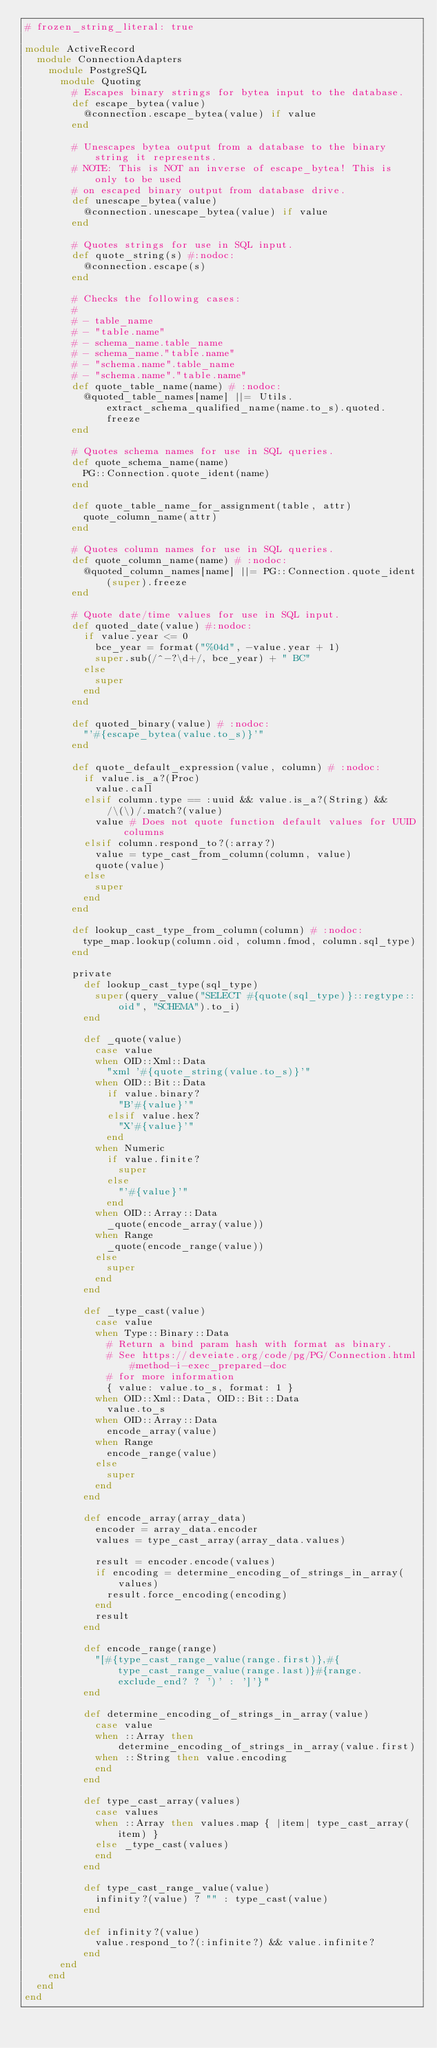Convert code to text. <code><loc_0><loc_0><loc_500><loc_500><_Ruby_># frozen_string_literal: true

module ActiveRecord
  module ConnectionAdapters
    module PostgreSQL
      module Quoting
        # Escapes binary strings for bytea input to the database.
        def escape_bytea(value)
          @connection.escape_bytea(value) if value
        end

        # Unescapes bytea output from a database to the binary string it represents.
        # NOTE: This is NOT an inverse of escape_bytea! This is only to be used
        # on escaped binary output from database drive.
        def unescape_bytea(value)
          @connection.unescape_bytea(value) if value
        end

        # Quotes strings for use in SQL input.
        def quote_string(s) #:nodoc:
          @connection.escape(s)
        end

        # Checks the following cases:
        #
        # - table_name
        # - "table.name"
        # - schema_name.table_name
        # - schema_name."table.name"
        # - "schema.name".table_name
        # - "schema.name"."table.name"
        def quote_table_name(name) # :nodoc:
          @quoted_table_names[name] ||= Utils.extract_schema_qualified_name(name.to_s).quoted.freeze
        end

        # Quotes schema names for use in SQL queries.
        def quote_schema_name(name)
          PG::Connection.quote_ident(name)
        end

        def quote_table_name_for_assignment(table, attr)
          quote_column_name(attr)
        end

        # Quotes column names for use in SQL queries.
        def quote_column_name(name) # :nodoc:
          @quoted_column_names[name] ||= PG::Connection.quote_ident(super).freeze
        end

        # Quote date/time values for use in SQL input.
        def quoted_date(value) #:nodoc:
          if value.year <= 0
            bce_year = format("%04d", -value.year + 1)
            super.sub(/^-?\d+/, bce_year) + " BC"
          else
            super
          end
        end

        def quoted_binary(value) # :nodoc:
          "'#{escape_bytea(value.to_s)}'"
        end

        def quote_default_expression(value, column) # :nodoc:
          if value.is_a?(Proc)
            value.call
          elsif column.type == :uuid && value.is_a?(String) && /\(\)/.match?(value)
            value # Does not quote function default values for UUID columns
          elsif column.respond_to?(:array?)
            value = type_cast_from_column(column, value)
            quote(value)
          else
            super
          end
        end

        def lookup_cast_type_from_column(column) # :nodoc:
          type_map.lookup(column.oid, column.fmod, column.sql_type)
        end

        private
          def lookup_cast_type(sql_type)
            super(query_value("SELECT #{quote(sql_type)}::regtype::oid", "SCHEMA").to_i)
          end

          def _quote(value)
            case value
            when OID::Xml::Data
              "xml '#{quote_string(value.to_s)}'"
            when OID::Bit::Data
              if value.binary?
                "B'#{value}'"
              elsif value.hex?
                "X'#{value}'"
              end
            when Numeric
              if value.finite?
                super
              else
                "'#{value}'"
              end
            when OID::Array::Data
              _quote(encode_array(value))
            when Range
              _quote(encode_range(value))
            else
              super
            end
          end

          def _type_cast(value)
            case value
            when Type::Binary::Data
              # Return a bind param hash with format as binary.
              # See https://deveiate.org/code/pg/PG/Connection.html#method-i-exec_prepared-doc
              # for more information
              { value: value.to_s, format: 1 }
            when OID::Xml::Data, OID::Bit::Data
              value.to_s
            when OID::Array::Data
              encode_array(value)
            when Range
              encode_range(value)
            else
              super
            end
          end

          def encode_array(array_data)
            encoder = array_data.encoder
            values = type_cast_array(array_data.values)

            result = encoder.encode(values)
            if encoding = determine_encoding_of_strings_in_array(values)
              result.force_encoding(encoding)
            end
            result
          end

          def encode_range(range)
            "[#{type_cast_range_value(range.first)},#{type_cast_range_value(range.last)}#{range.exclude_end? ? ')' : ']'}"
          end

          def determine_encoding_of_strings_in_array(value)
            case value
            when ::Array then determine_encoding_of_strings_in_array(value.first)
            when ::String then value.encoding
            end
          end

          def type_cast_array(values)
            case values
            when ::Array then values.map { |item| type_cast_array(item) }
            else _type_cast(values)
            end
          end

          def type_cast_range_value(value)
            infinity?(value) ? "" : type_cast(value)
          end

          def infinity?(value)
            value.respond_to?(:infinite?) && value.infinite?
          end
      end
    end
  end
end
</code> 